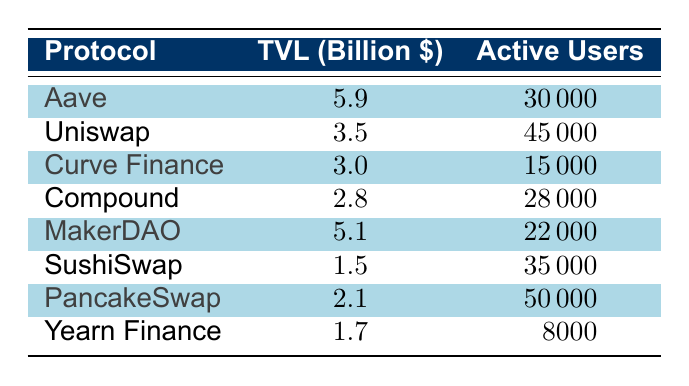What is the total value locked (TVL) for Aave? According to the table, the TVL for Aave is listed directly as 5.9 billion dollars.
Answer: 5.9 billion dollars Which protocol has the highest number of active users? From the table, PancakeSwap has the highest number of active users at 50,000, comparing it with other protocols which have lesser active users.
Answer: PancakeSwap How many DeFi protocols have a TVL greater than 3 billion dollars? By evaluating the values in the TVL column, Aave (5.9), MakerDAO (5.1), and Uniswap (3.5) are the only protocols that exceed 3 billion dollars. Thus, there are 3 protocols in total.
Answer: 3 Is the TVL of Curve Finance greater than that of Compound? The TVL for Curve Finance is 3.0 billion dollars and for Compound, it is 2.8 billion dollars. Since 3.0 is greater than 2.8, the statement is true.
Answer: Yes What is the average TVL of all the protocols listed? To find the average, first sum up the TVLs: 5.9 + 3.5 + 3.0 + 2.8 + 5.1 + 1.5 + 2.1 + 1.7 = 25.6 billion dollars. Then divide by the number of protocols (8): 25.6 / 8 = 3.2 billion dollars.
Answer: 3.2 billion dollars Which protocol has more active users, MakerDAO or Yearn Finance? The active users for MakerDAO are 22,000, and for Yearn Finance, it is 8,000. Since 22,000 is greater than 8,000, MakerDAO has more active users.
Answer: MakerDAO What is the difference in TVL between Uniswap and SushiSwap? Uniswap has a TVL of 3.5 billion dollars and SushiSwap has a TVL of 1.5 billion dollars. The difference can be calculated as 3.5 - 1.5 = 2.0 billion dollars.
Answer: 2.0 billion dollars Are there more active users on Compound than on Curve Finance? The number of active users for Compound is 28,000, while for Curve Finance, it is 15,000. Thus, Compound does have more active users than Curve Finance.
Answer: Yes What is the total number of active users across all protocols? By summing the active users of all protocols, we get: 30,000 + 45,000 + 15,000 + 28,000 + 22,000 + 35,000 + 50,000 + 8,000 = 233,000 active users in total.
Answer: 233,000 active users 